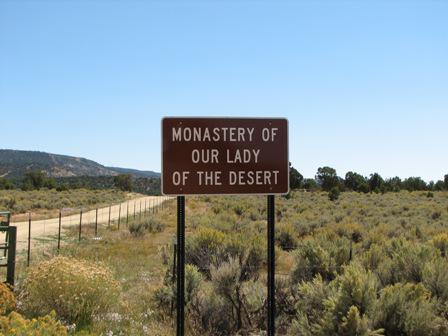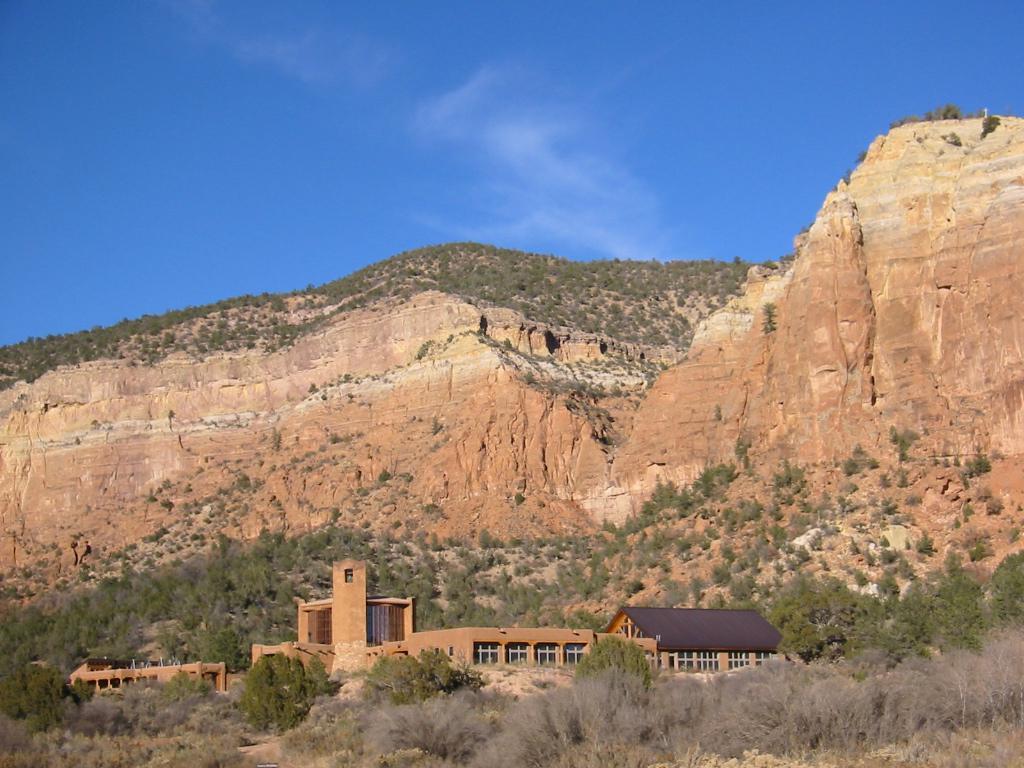The first image is the image on the left, the second image is the image on the right. Given the left and right images, does the statement "There are women and no men in the left image." hold true? Answer yes or no. No. The first image is the image on the left, the second image is the image on the right. For the images shown, is this caption "At least 10 nuns are posing as a group in one of the pictures." true? Answer yes or no. No. 